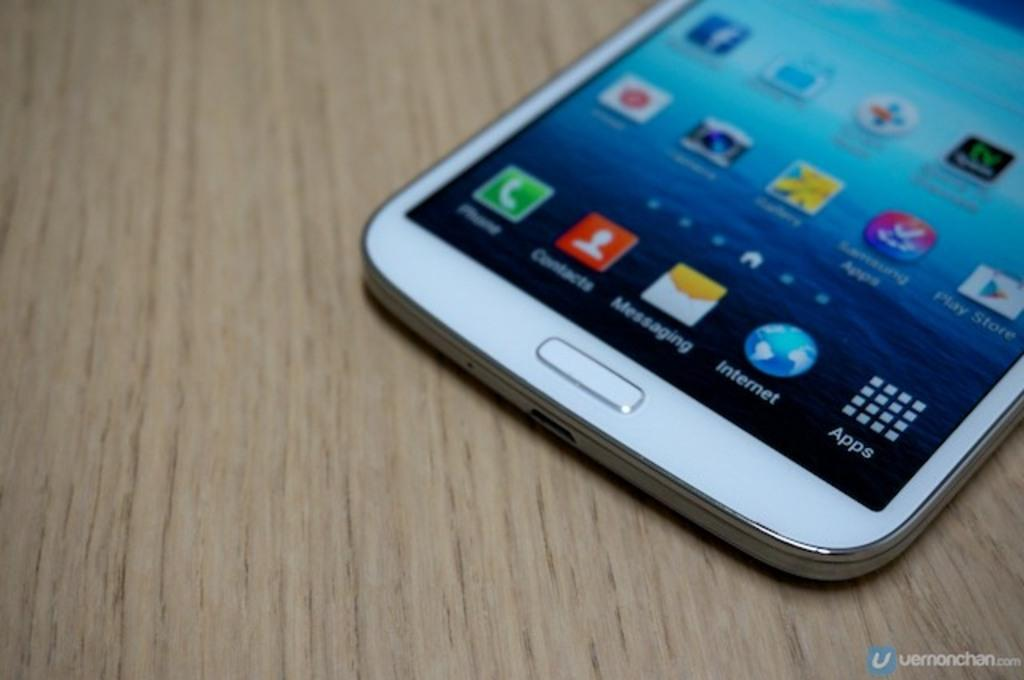What electronic device is present in the image? There is a mobile phone in the image. Where is the mobile phone located? The mobile phone is on a wooden table. What can be seen on the screen of the mobile phone? The screen of the mobile phone displays application icons. What type of wool is being used to create a lamp in the image? There is no wool or lamp present in the image; it only features a mobile phone on a wooden table. 